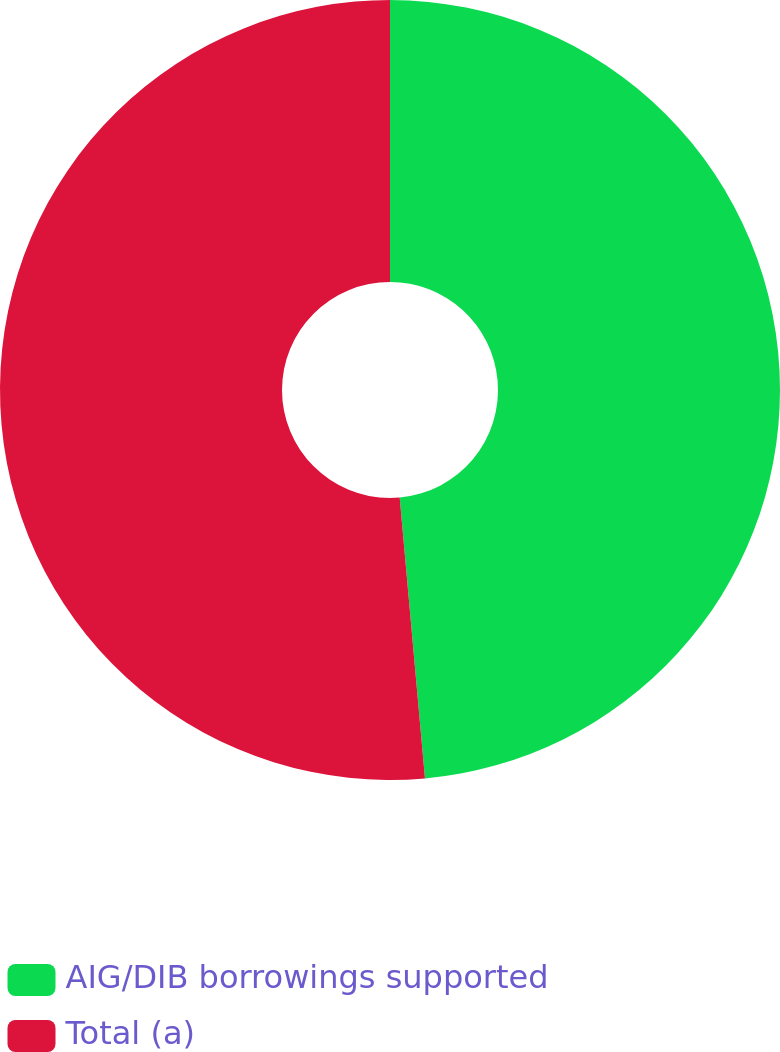Convert chart to OTSL. <chart><loc_0><loc_0><loc_500><loc_500><pie_chart><fcel>AIG/DIB borrowings supported<fcel>Total (a)<nl><fcel>48.57%<fcel>51.43%<nl></chart> 